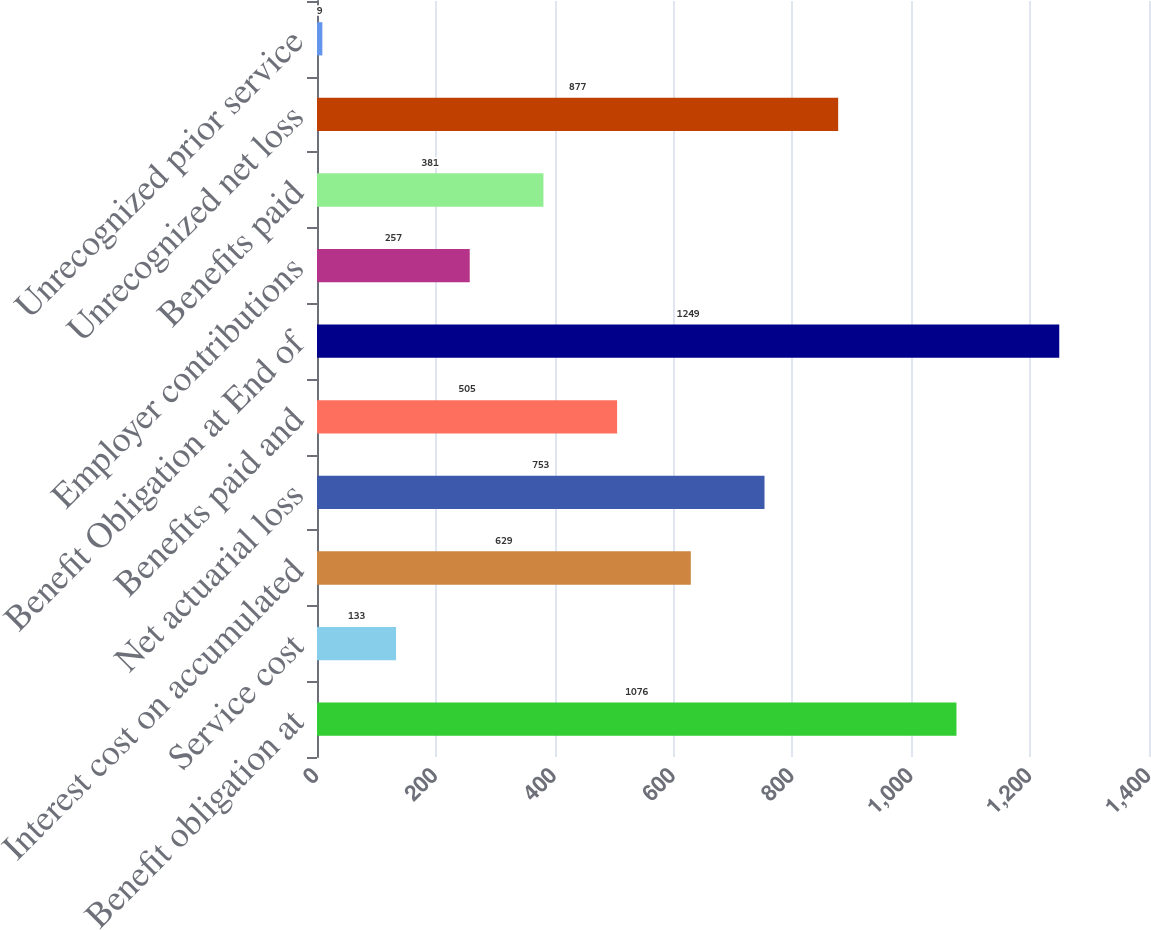Convert chart to OTSL. <chart><loc_0><loc_0><loc_500><loc_500><bar_chart><fcel>Benefit obligation at<fcel>Service cost<fcel>Interest cost on accumulated<fcel>Net actuarial loss<fcel>Benefits paid and<fcel>Benefit Obligation at End of<fcel>Employer contributions<fcel>Benefits paid<fcel>Unrecognized net loss<fcel>Unrecognized prior service<nl><fcel>1076<fcel>133<fcel>629<fcel>753<fcel>505<fcel>1249<fcel>257<fcel>381<fcel>877<fcel>9<nl></chart> 